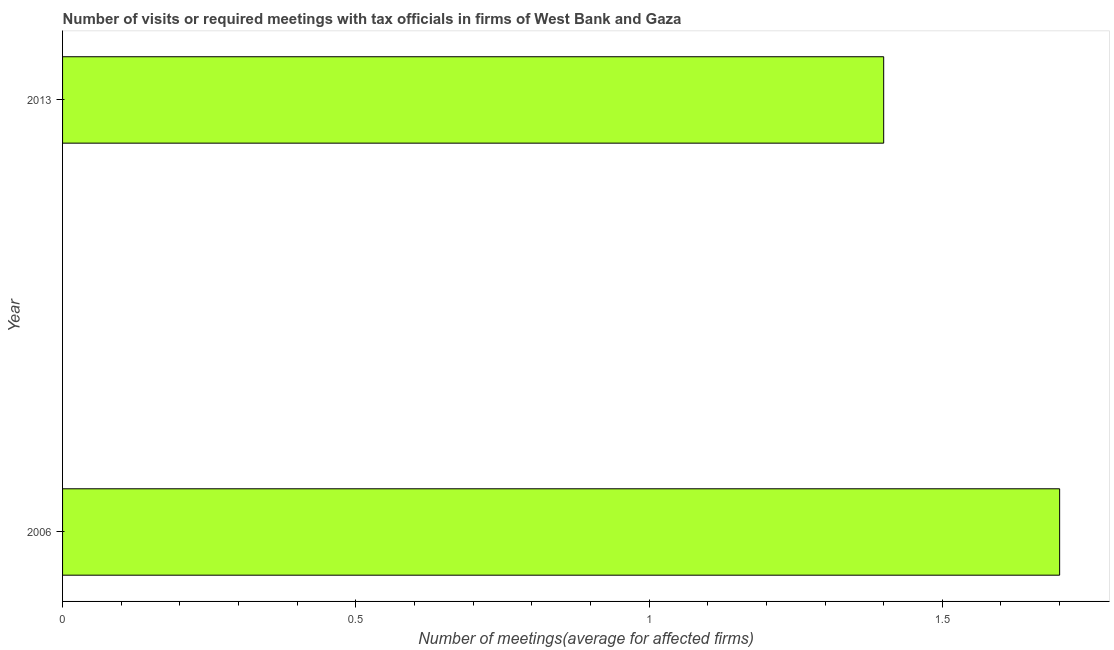What is the title of the graph?
Give a very brief answer. Number of visits or required meetings with tax officials in firms of West Bank and Gaza. What is the label or title of the X-axis?
Offer a terse response. Number of meetings(average for affected firms). What is the label or title of the Y-axis?
Ensure brevity in your answer.  Year. Across all years, what is the maximum number of required meetings with tax officials?
Give a very brief answer. 1.7. Across all years, what is the minimum number of required meetings with tax officials?
Offer a very short reply. 1.4. In which year was the number of required meetings with tax officials maximum?
Ensure brevity in your answer.  2006. What is the sum of the number of required meetings with tax officials?
Your answer should be compact. 3.1. What is the average number of required meetings with tax officials per year?
Make the answer very short. 1.55. What is the median number of required meetings with tax officials?
Your answer should be very brief. 1.55. What is the ratio of the number of required meetings with tax officials in 2006 to that in 2013?
Your response must be concise. 1.21. How many bars are there?
Make the answer very short. 2. Are all the bars in the graph horizontal?
Your answer should be compact. Yes. What is the difference between two consecutive major ticks on the X-axis?
Offer a very short reply. 0.5. What is the Number of meetings(average for affected firms) of 2006?
Make the answer very short. 1.7. What is the Number of meetings(average for affected firms) in 2013?
Provide a short and direct response. 1.4. What is the ratio of the Number of meetings(average for affected firms) in 2006 to that in 2013?
Keep it short and to the point. 1.21. 